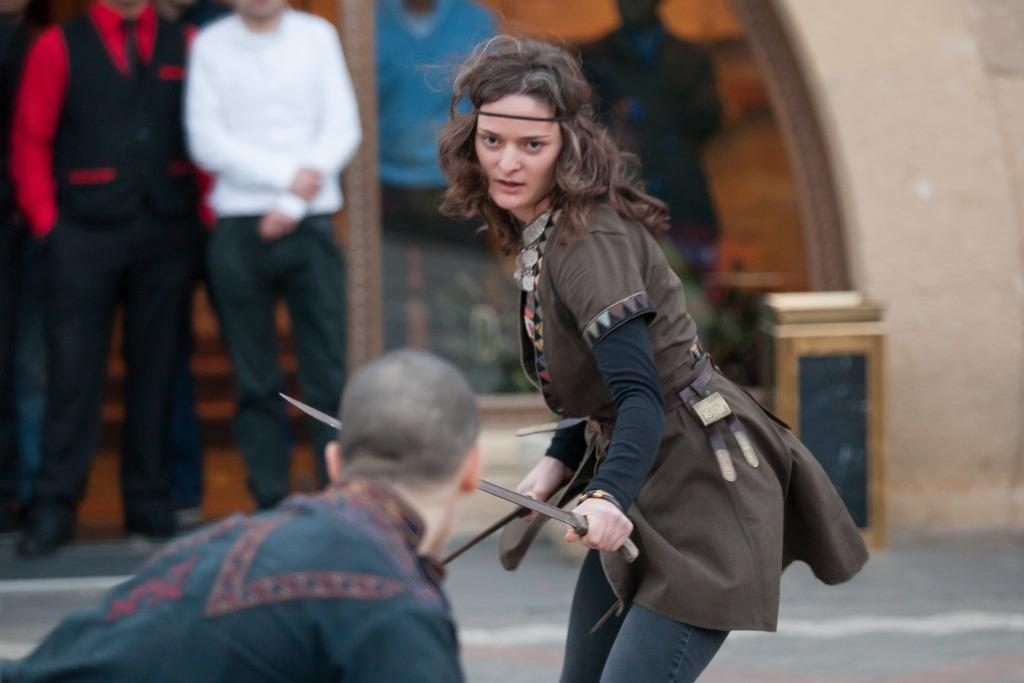How many people are present in the image? There are two people in the image, a man and a woman. What is the woman holding in her hands? The woman is holding swords in both her hands. What type of powder can be seen on the ground in the image? There is no powder visible on the ground in the image. 